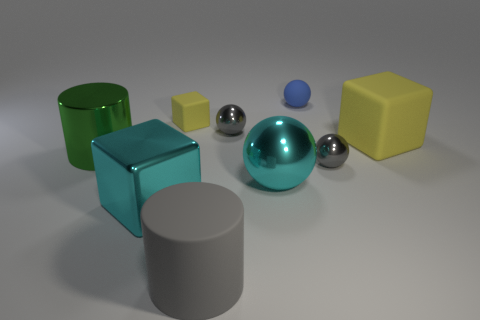Subtract 1 balls. How many balls are left? 3 Subtract all cyan balls. How many balls are left? 3 Add 1 large cyan things. How many objects exist? 10 Subtract 0 yellow spheres. How many objects are left? 9 Subtract all balls. How many objects are left? 5 Subtract all big cyan balls. Subtract all small blue balls. How many objects are left? 7 Add 1 large cyan metal blocks. How many large cyan metal blocks are left? 2 Add 9 small cyan spheres. How many small cyan spheres exist? 9 